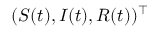Convert formula to latex. <formula><loc_0><loc_0><loc_500><loc_500>( S ( t ) , I ( t ) , R ( t ) ) ^ { \top }</formula> 